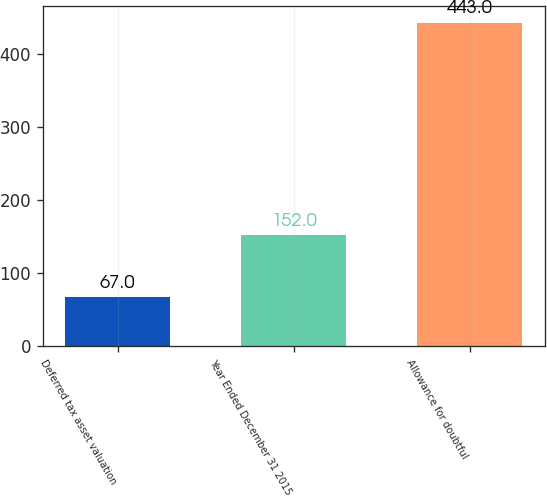Convert chart to OTSL. <chart><loc_0><loc_0><loc_500><loc_500><bar_chart><fcel>Deferred tax asset valuation<fcel>Year Ended December 31 2015<fcel>Allowance for doubtful<nl><fcel>67<fcel>152<fcel>443<nl></chart> 